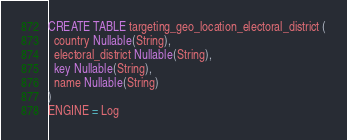Convert code to text. <code><loc_0><loc_0><loc_500><loc_500><_SQL_>CREATE TABLE targeting_geo_location_electoral_district (
  country Nullable(String),
  electoral_district Nullable(String),
  key Nullable(String),
  name Nullable(String)
)
ENGINE = Log
</code> 